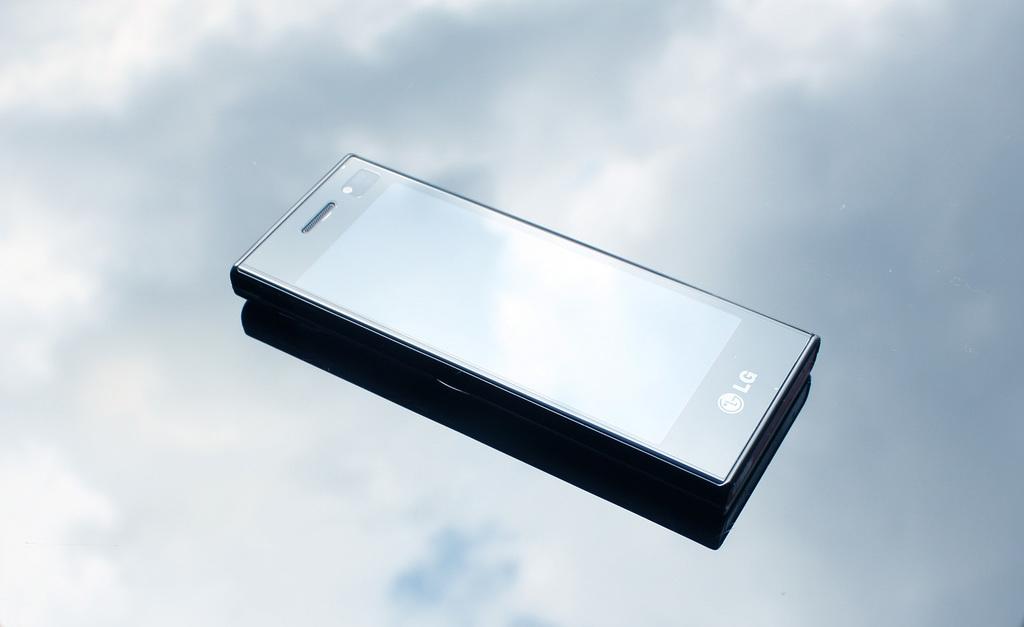What brand of phone is this?
Offer a terse response. Lg. 